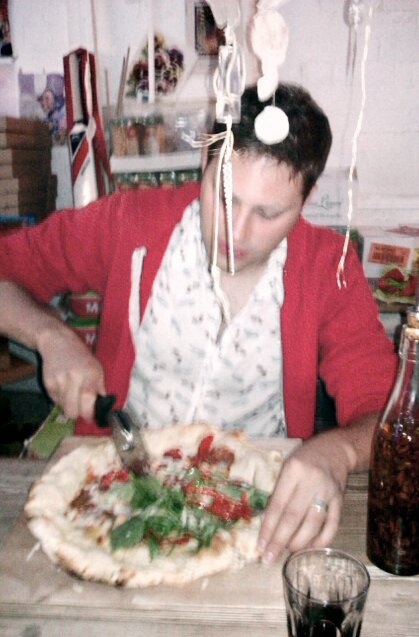Describe the objects in this image and their specific colors. I can see people in black, lightgray, brown, and pink tones, pizza in black, lightgray, tan, and darkgray tones, dining table in black, darkgray, and lightgray tones, bottle in black, maroon, gray, and brown tones, and cup in black, darkgray, and gray tones in this image. 